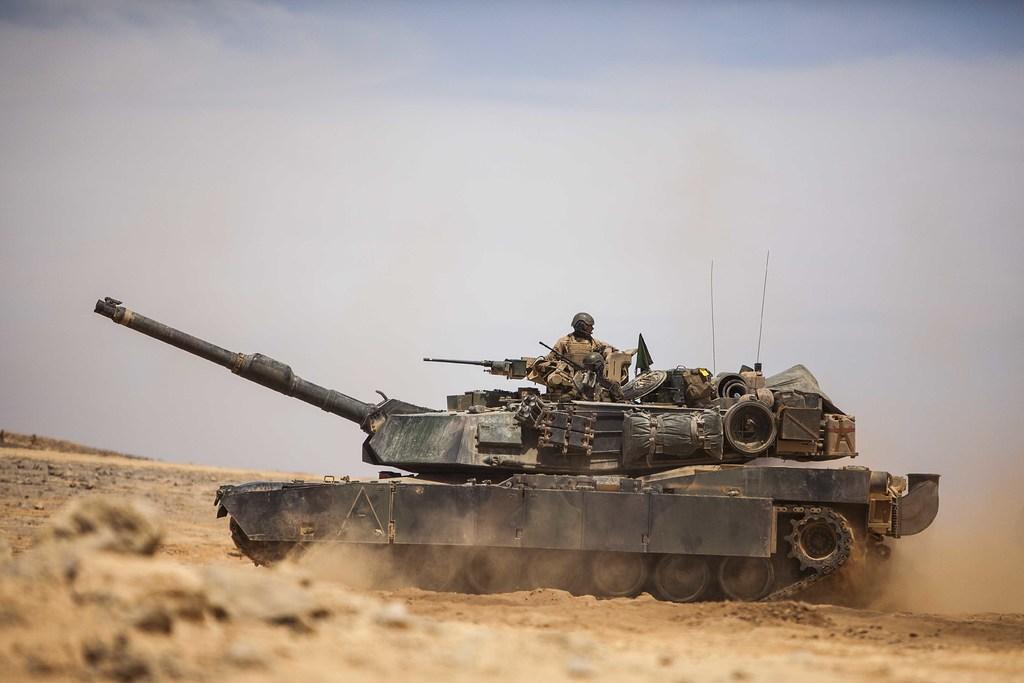Could you give a brief overview of what you see in this image? In this picture we can see a tank on the ground with a person on it. In the background we can see the sky. 